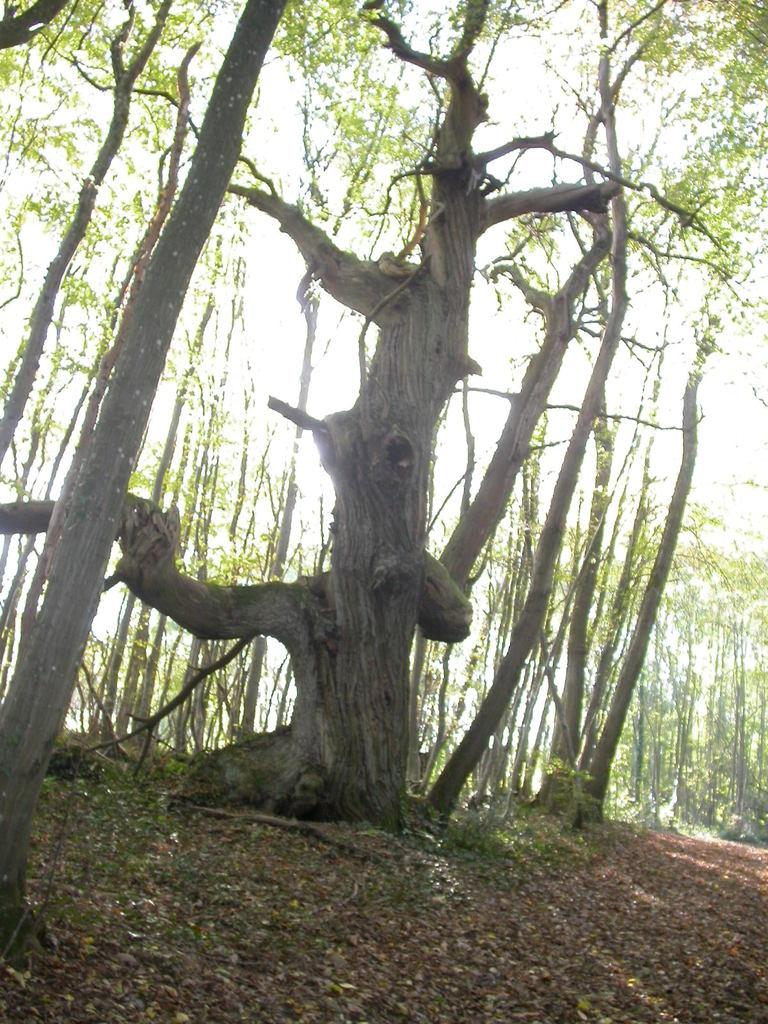What type of vegetation can be seen in the image? There are trees in the image. What is on the ground beneath the trees? There are leaves on the ground in the image. What can be observed about the lighting in the image? Sun rays are visible in the image, falling across the trees. What type of class is being taught in the image? There is no class or teaching activity present in the image. 